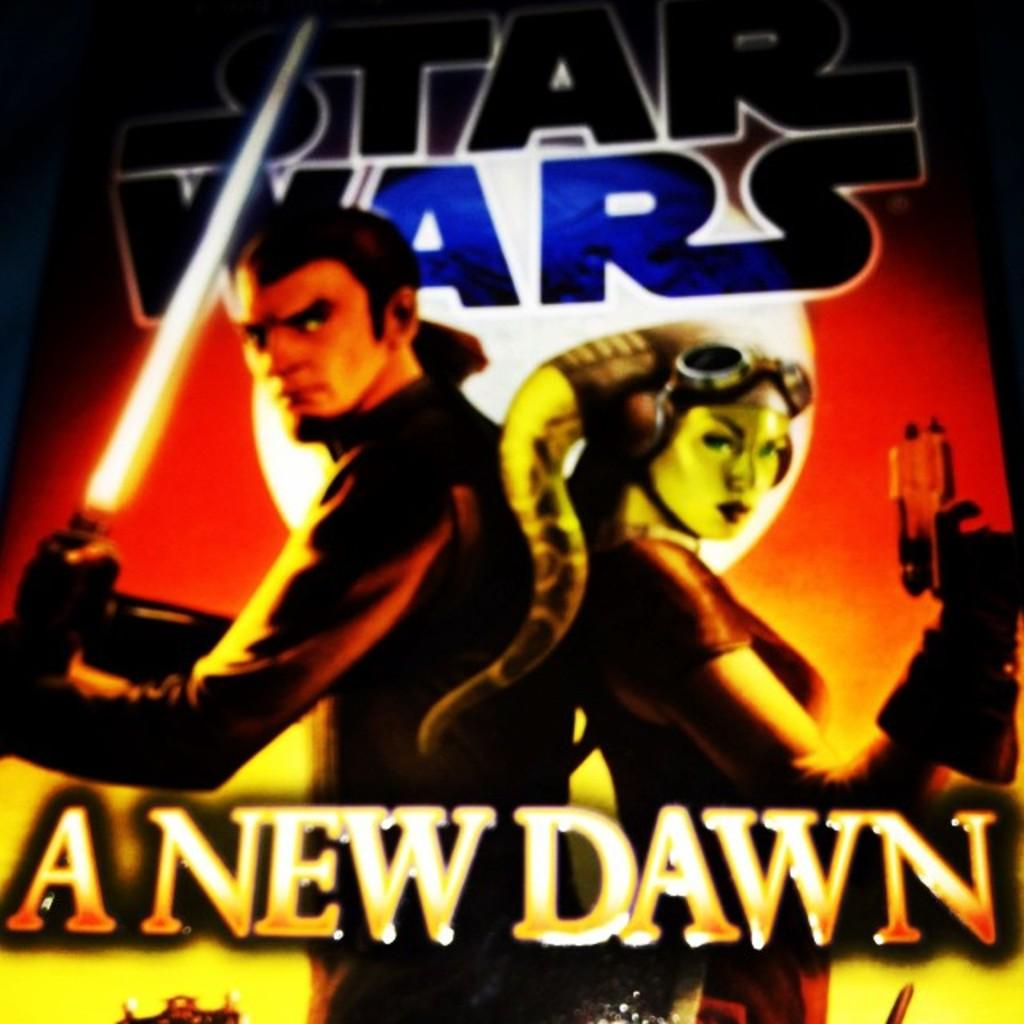What type of poster is in the image? There is an animated poster in the image. How many animated pictures are on the poster? The poster contains two animated pictures. Is there any text on the poster? Yes, there is text written on the poster. How many police officers are depicted in the animated pictures on the poster? There are no police officers depicted in the animated pictures on the poster, as the facts provided do not mention any police officers. 